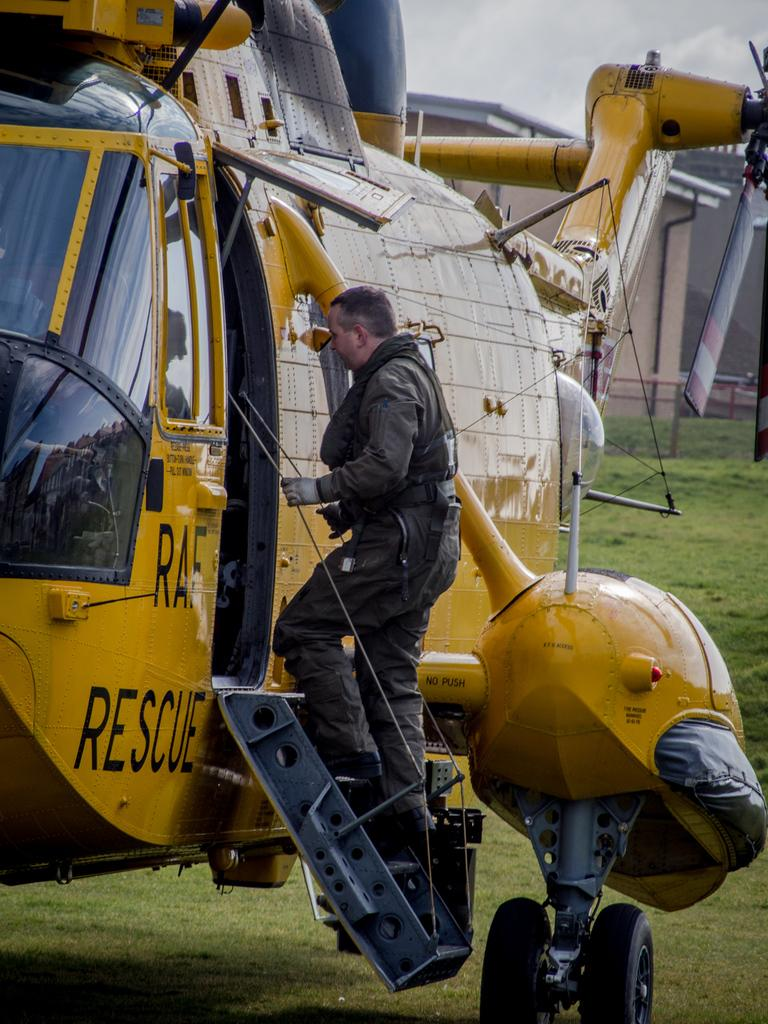<image>
Render a clear and concise summary of the photo. A man boards a yellow RAF rescue helicopter. 